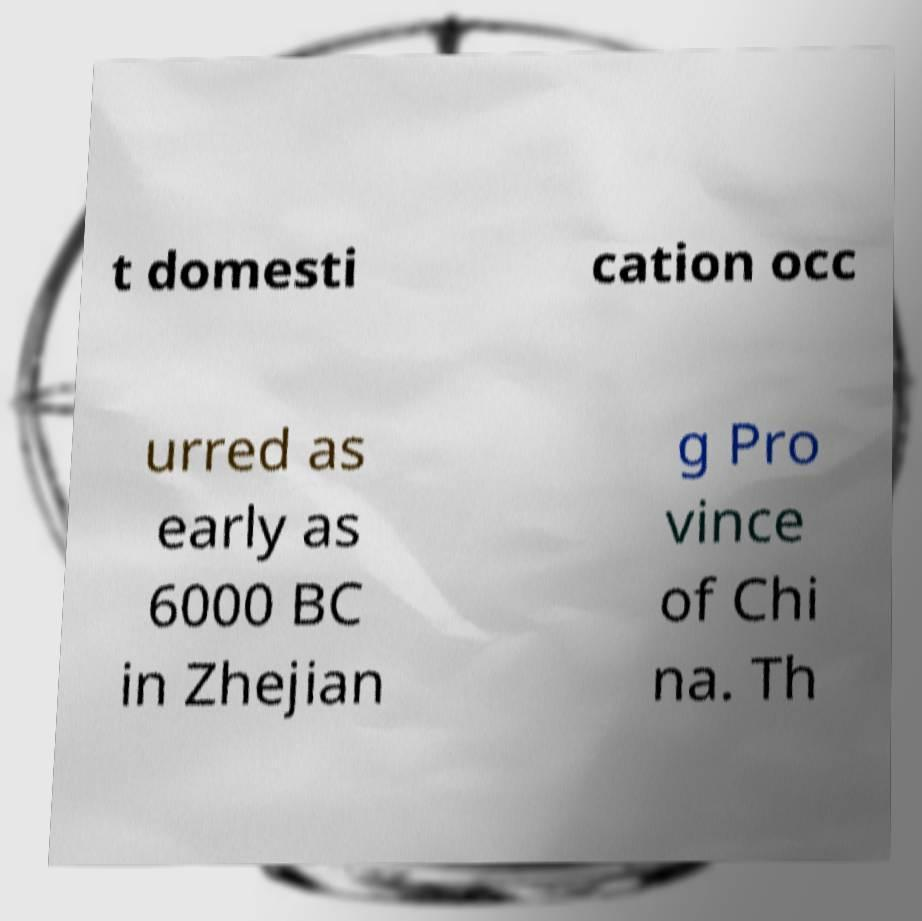Could you assist in decoding the text presented in this image and type it out clearly? t domesti cation occ urred as early as 6000 BC in Zhejian g Pro vince of Chi na. Th 